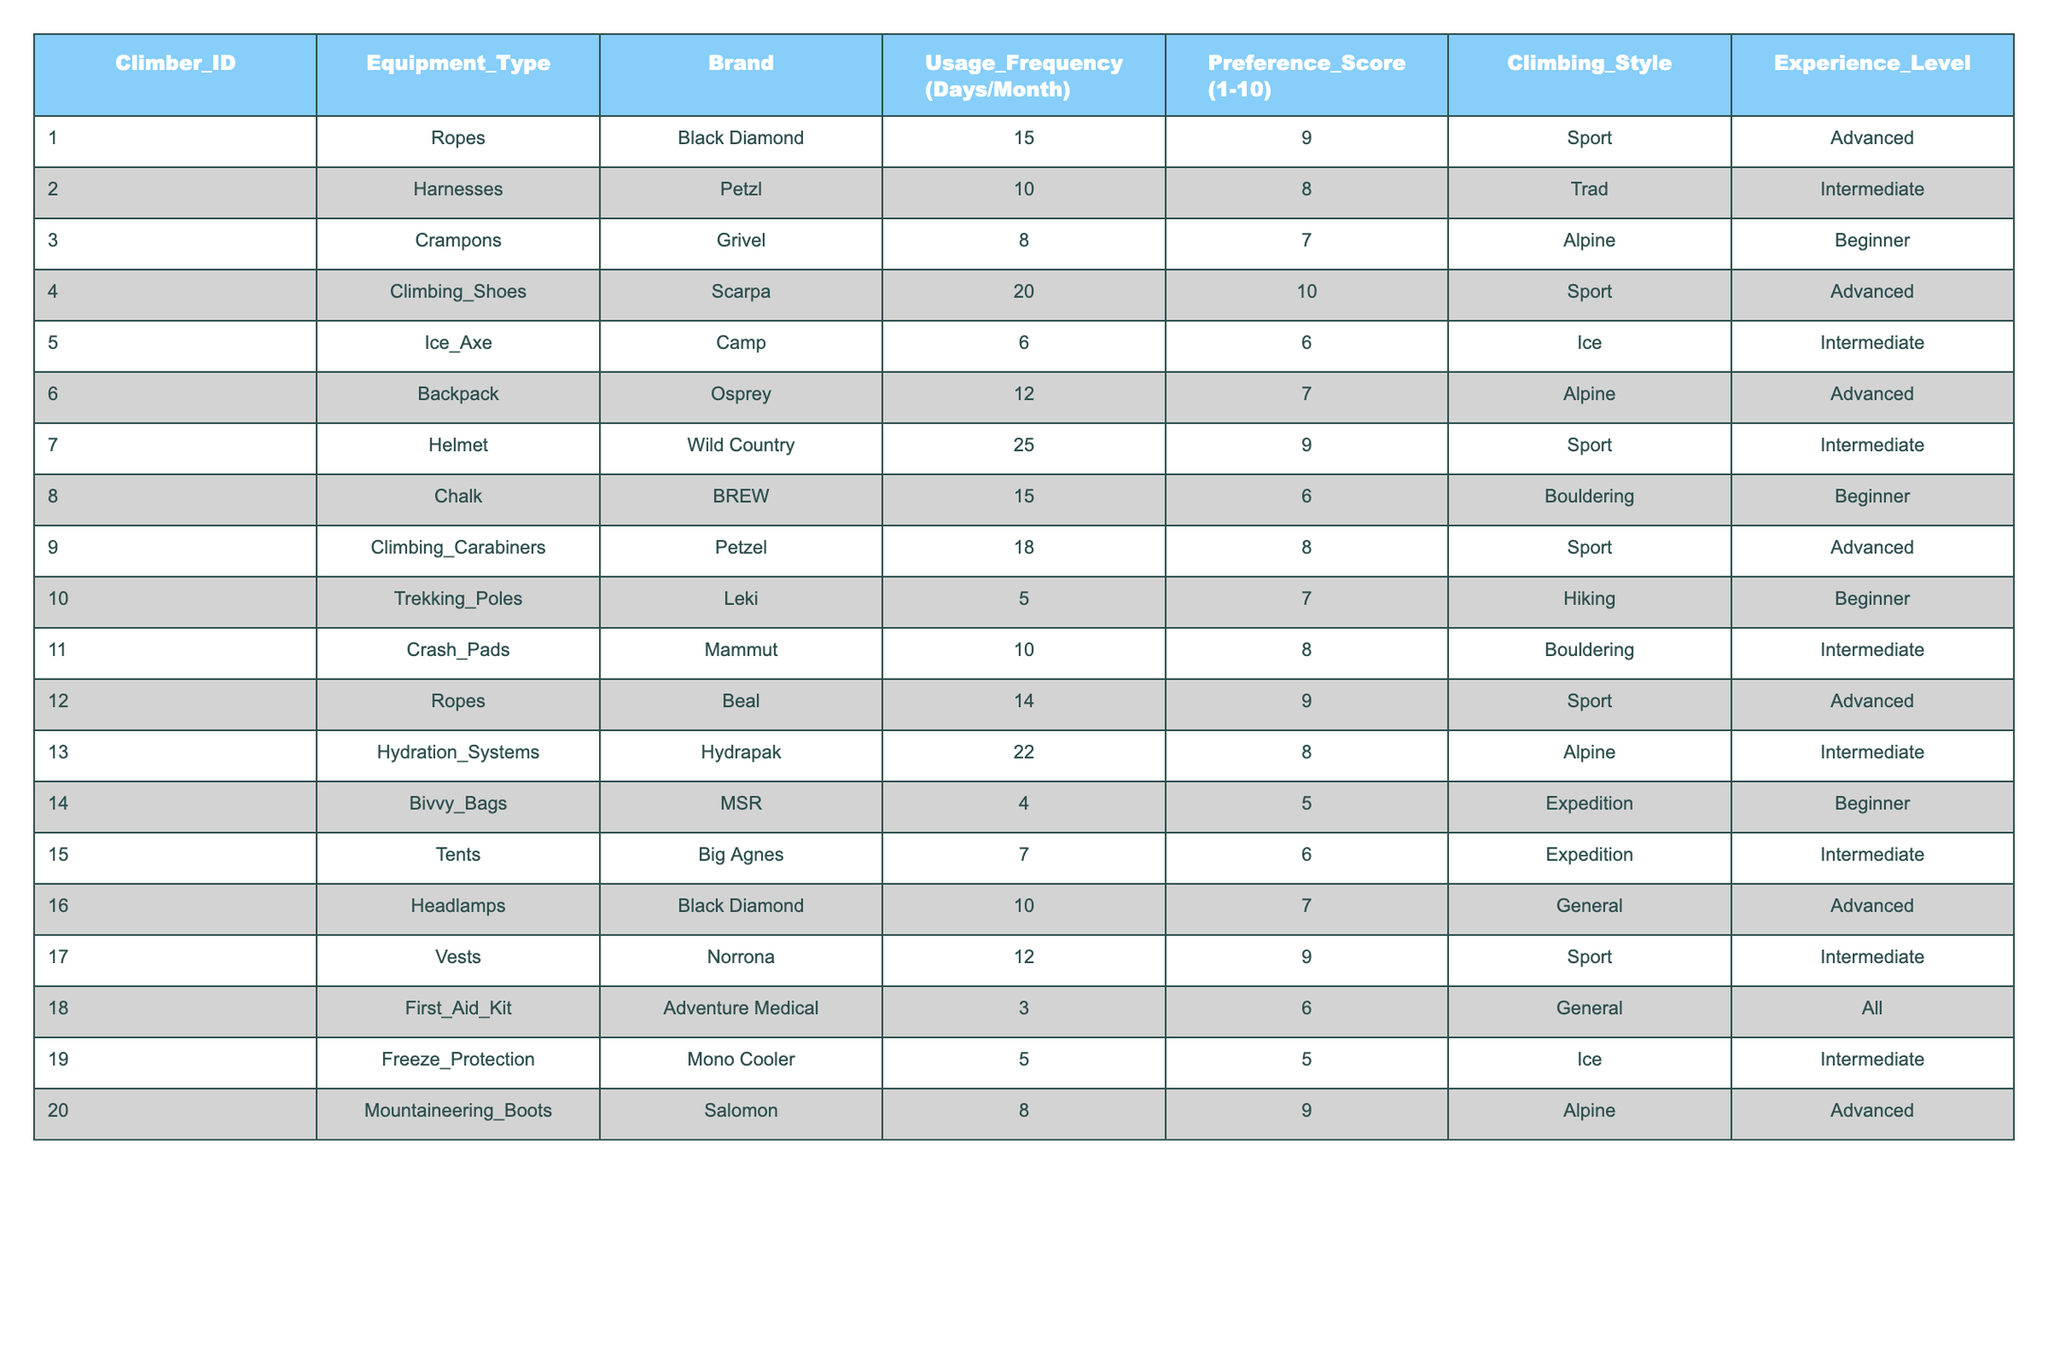What is the most frequently used equipment type among climbers? By scanning the Usage Frequency column, the highest value is 25 days/month for Helmets, making it the most frequently used equipment type.
Answer: Helmets What is the average Preference Score for Alpine climbing style? The Preference Scores for the Alpine style (7, 8, 9) sum to 24 and there are 3 entries, so the average is 24/3 = 8.
Answer: 8 Is the brand Black Diamond used for any equipment? Yes, Black Diamond appears twice in the table, for Ropes and Headlamps.
Answer: Yes Which equipment type has the highest Preference Score and what is that score? Climbing Shoes have the highest Preference Score of 10, as stated in the Preference Score column.
Answer: Climbing Shoes, 10 What is the total usage frequency for all types of equipment used by Advanced climbers? The sum of Usage Frequencies for Advanced climbers (15 + 20 + 25 + 14 + 12 + 8) = 94 days/month.
Answer: 94 Which climbing style uses the least equipment based on the table? By looking through the Climbing Styles, the Expedition style has the least entries (2), indicating it uses less equipment.
Answer: Expedition What percentage of the equipment listed is classified under the Sport climbing style? There are 6 entries under Sport out of 20 total entries, so the percentage is (6/20) * 100 = 30%.
Answer: 30% What do the Preference Scores indicate about the usage of Crash Pads compared to Ice Axes? Crash Pads have a Preference Score of 8 and are used 10 days/month while Ice Axes have a Preference Score of 6 and are used 6 days/month, indicating higher preference for Crash Pads despite less usage frequency.
Answer: Crash Pads are preferred over Ice Axes Which two brands have the lowest average usage frequency among climbers? The equipment with the lowest usage frequencies are Bivvy Bags (4 days/month) and Freeze Protection (5 days/month) and analyzing the brands shows that MSR and Mono Cooler are the least used brands.
Answer: MSR and Mono Cooler 